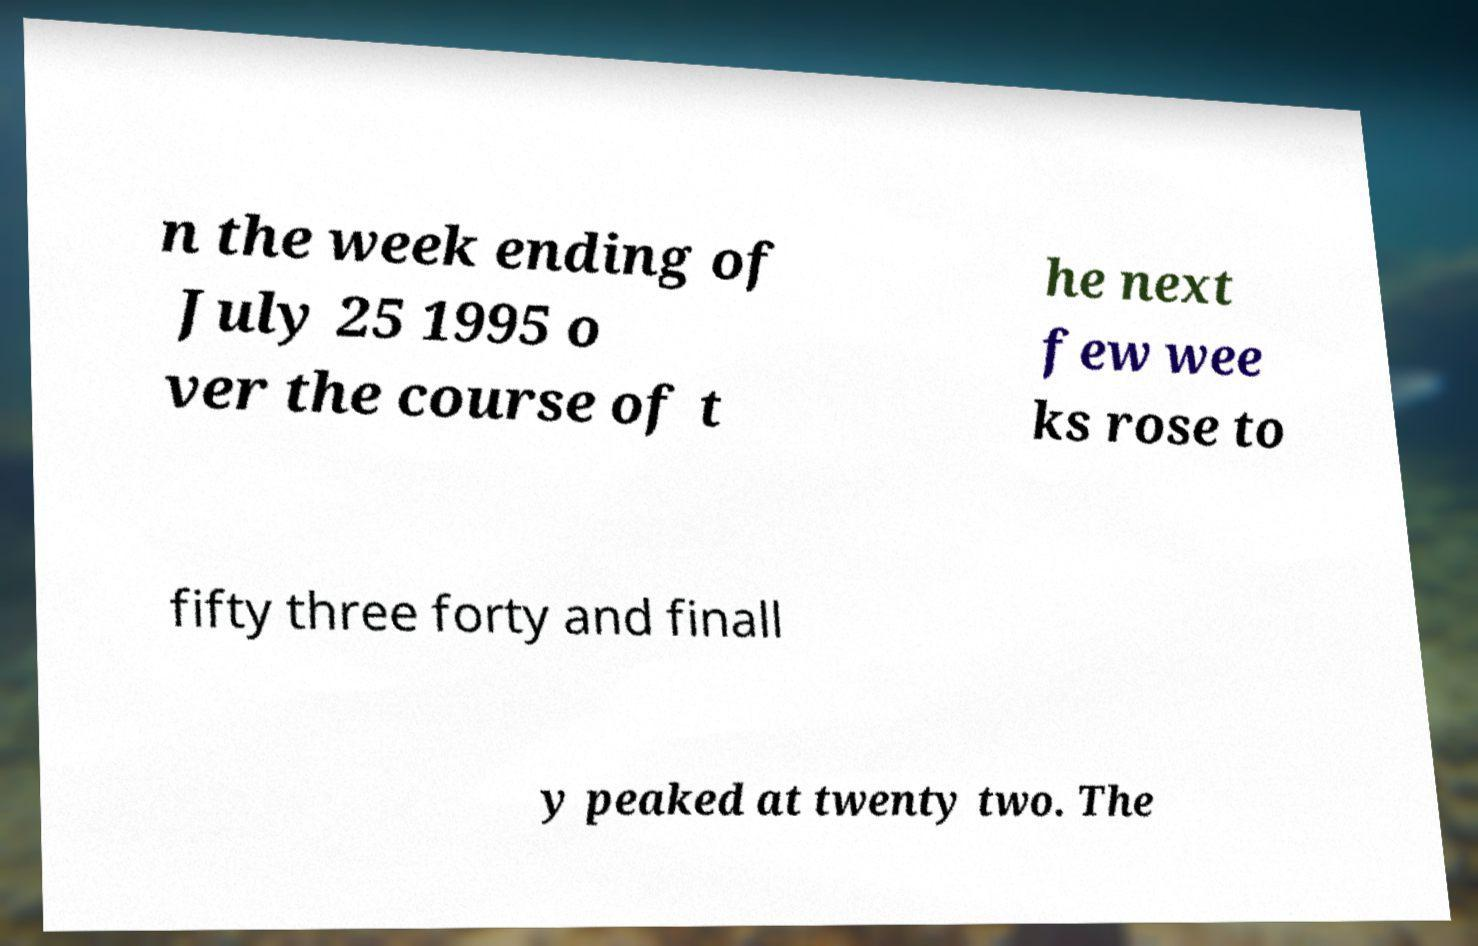For documentation purposes, I need the text within this image transcribed. Could you provide that? n the week ending of July 25 1995 o ver the course of t he next few wee ks rose to fifty three forty and finall y peaked at twenty two. The 